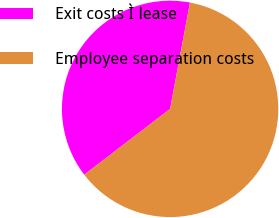Convert chart. <chart><loc_0><loc_0><loc_500><loc_500><pie_chart><fcel>Exit costs Ì lease<fcel>Employee separation costs<nl><fcel>38.35%<fcel>61.65%<nl></chart> 